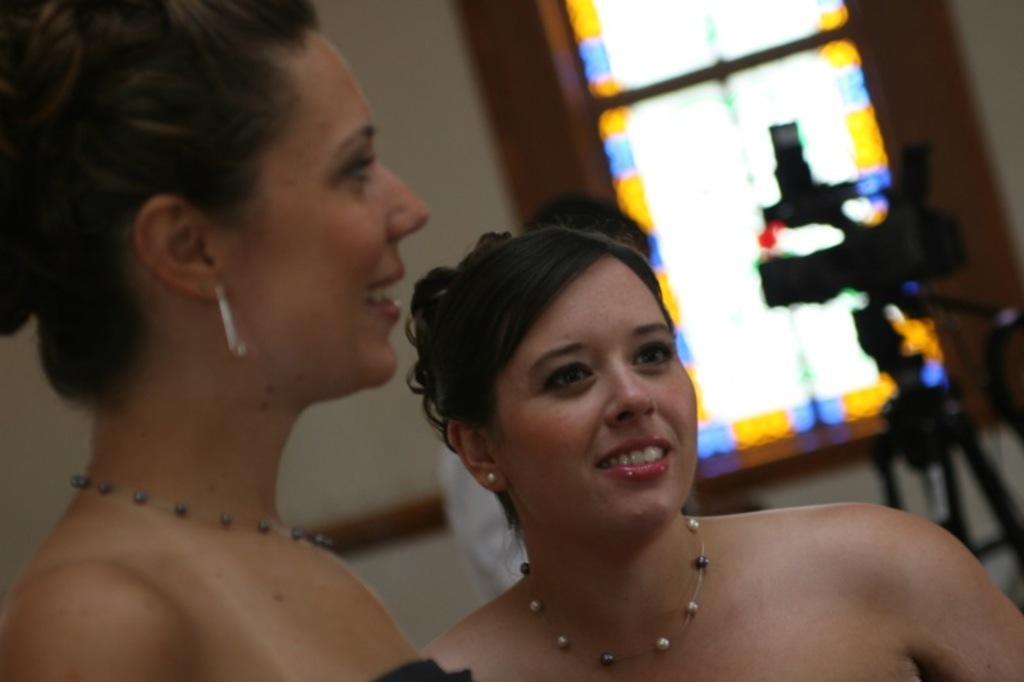Describe this image in one or two sentences. In this image there are two persons, in this image there is a camera on the stand, there is a window. 